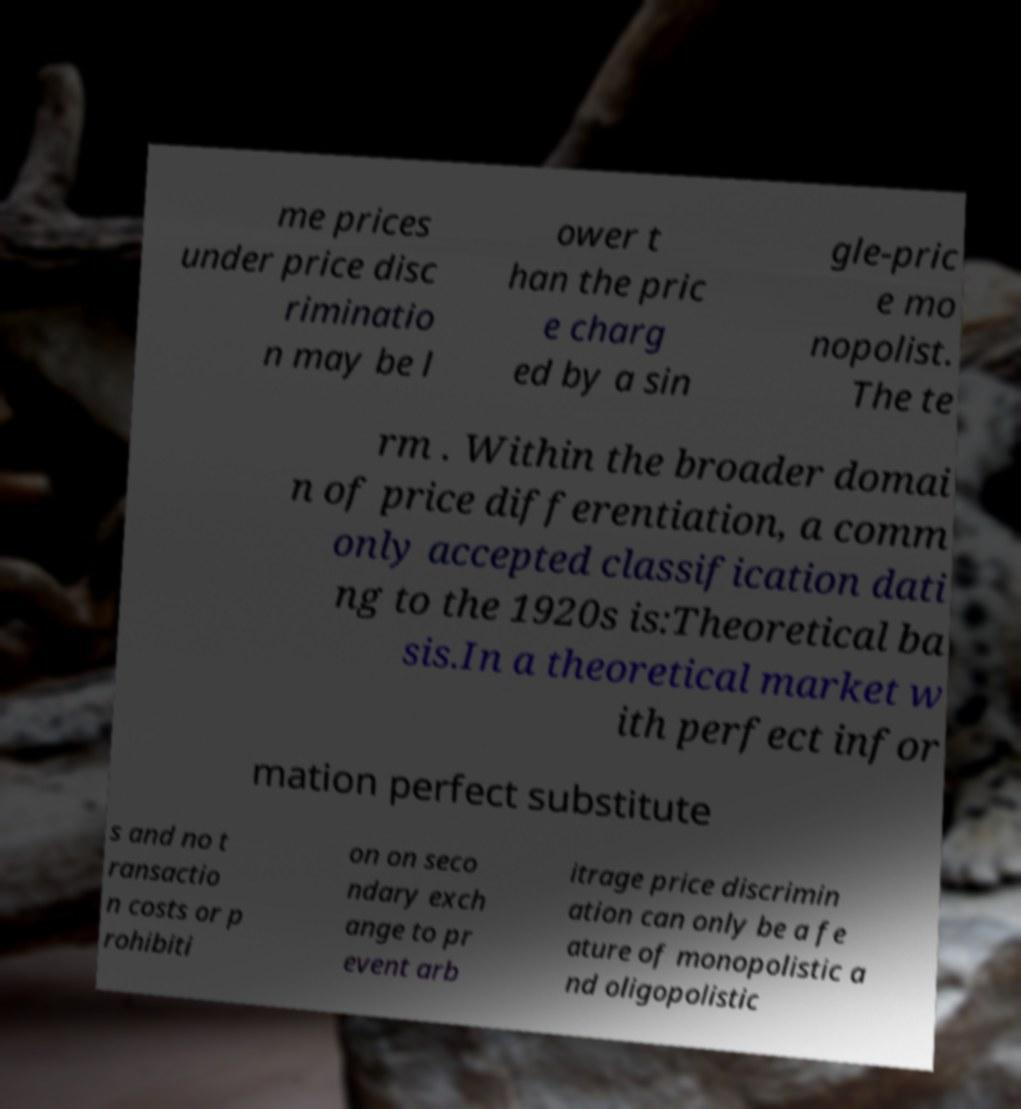Can you read and provide the text displayed in the image?This photo seems to have some interesting text. Can you extract and type it out for me? me prices under price disc riminatio n may be l ower t han the pric e charg ed by a sin gle-pric e mo nopolist. The te rm . Within the broader domai n of price differentiation, a comm only accepted classification dati ng to the 1920s is:Theoretical ba sis.In a theoretical market w ith perfect infor mation perfect substitute s and no t ransactio n costs or p rohibiti on on seco ndary exch ange to pr event arb itrage price discrimin ation can only be a fe ature of monopolistic a nd oligopolistic 